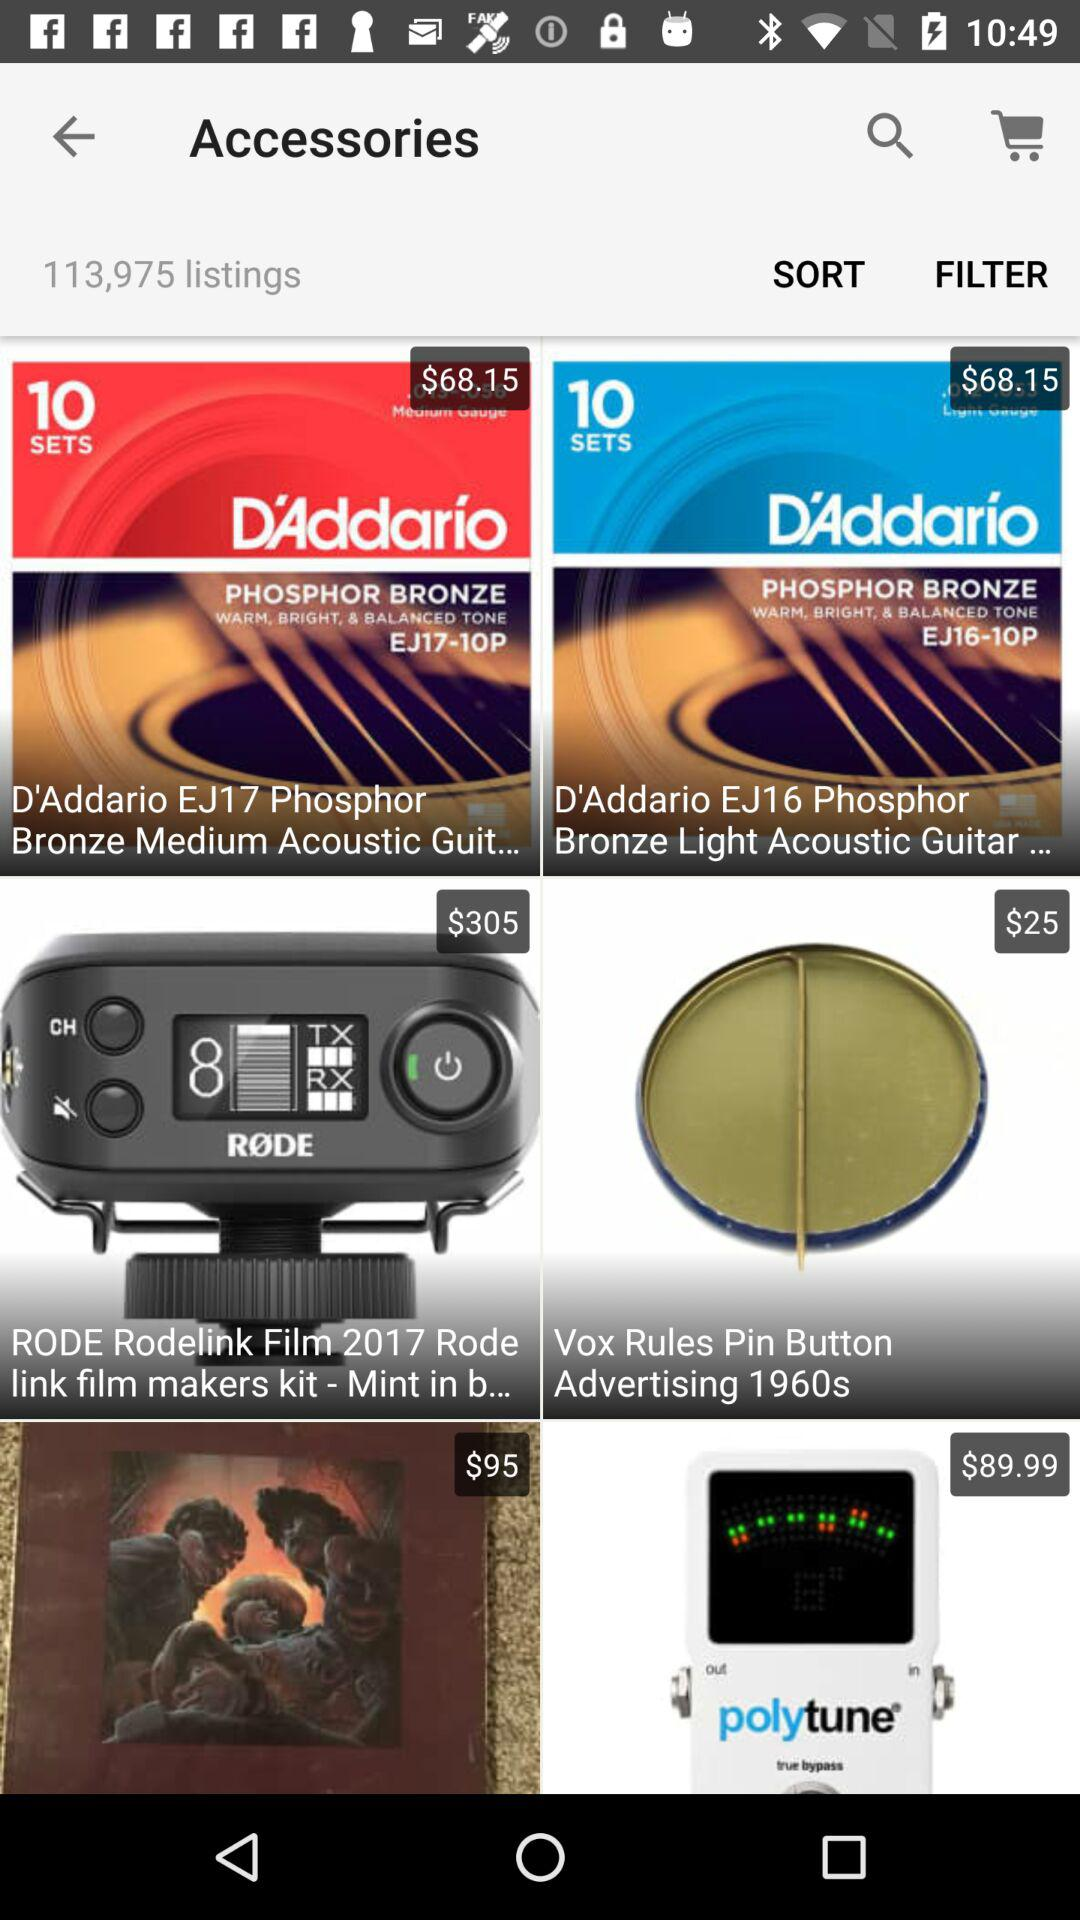Is there any item in the cart?
When the provided information is insufficient, respond with <no answer>. <no answer> 